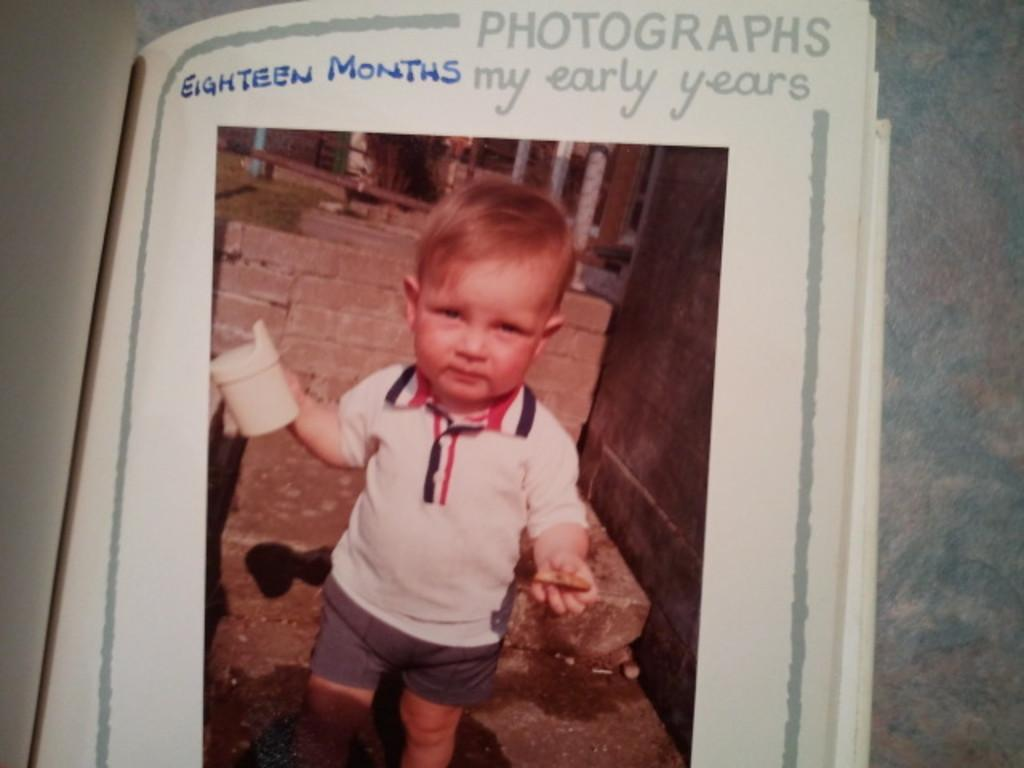What is the main object in the image? There is a book in the image. What can be seen in the book? The book contains a picture of a boy. What else is present in the book besides the picture? There is text in the book. What is the boy doing in the picture? The boy is holding an object. What type of quilt is being offered by the boy in the image? There is no quilt present in the image, and the boy is not offering anything. 